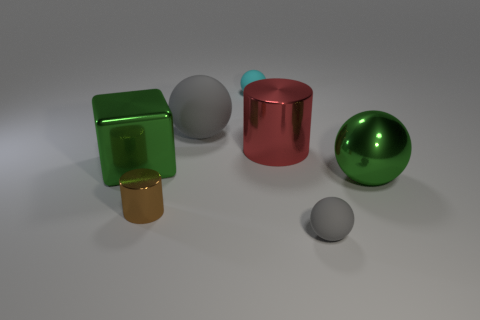Add 1 brown objects. How many objects exist? 8 Subtract all cylinders. How many objects are left? 5 Add 4 large blocks. How many large blocks are left? 5 Add 3 big red matte objects. How many big red matte objects exist? 3 Subtract 0 cyan blocks. How many objects are left? 7 Subtract all spheres. Subtract all large green metal objects. How many objects are left? 1 